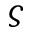<formula> <loc_0><loc_0><loc_500><loc_500>\varsigma</formula> 